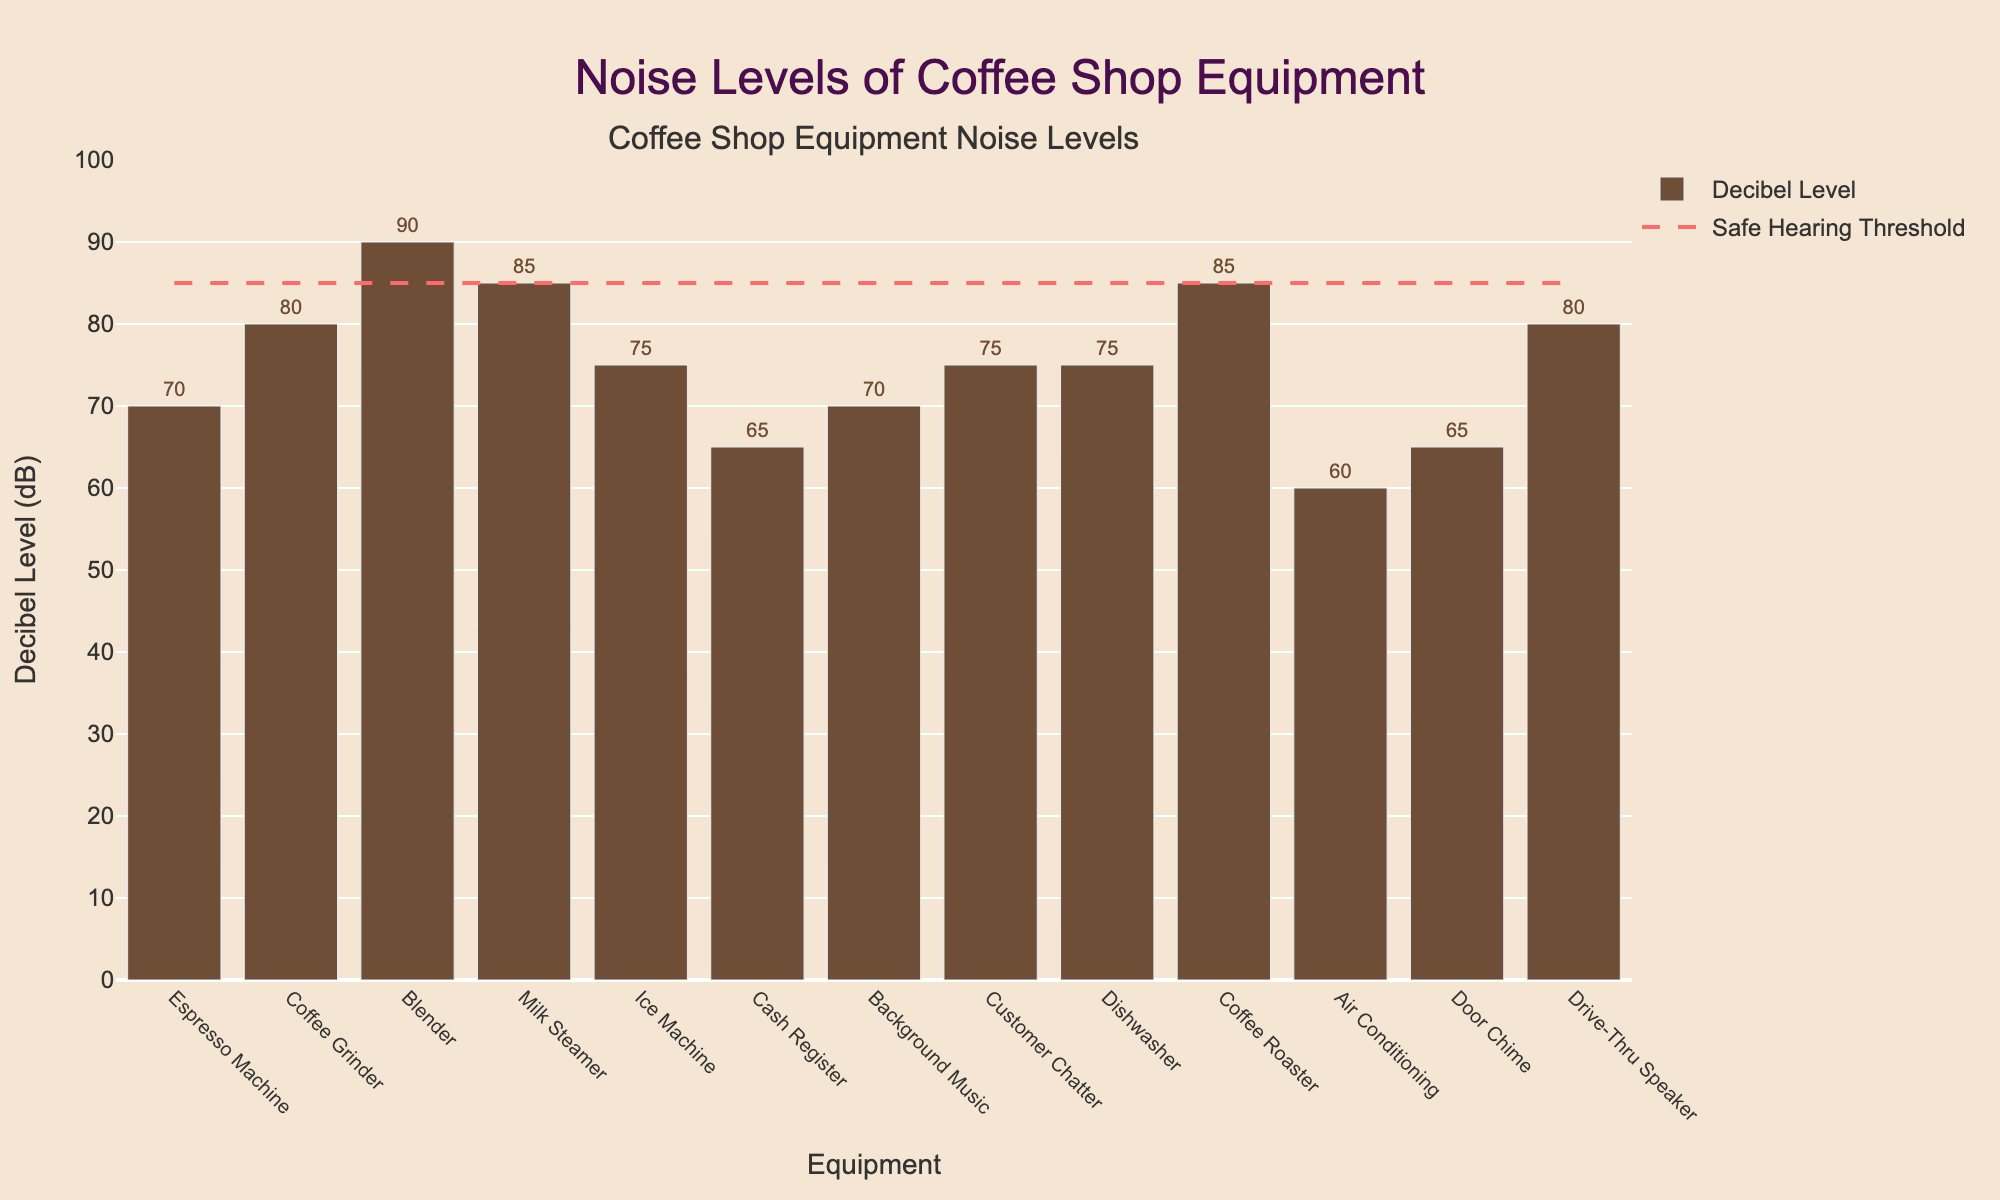Which equipment has the highest decibel level? By looking at the bar chart, the Blender has the highest bar, representing the highest decibel level among the equipment.
Answer: Blender Which equipment has decibel levels that exceed the safe hearing threshold? The bars that extend above the dashed line (safe hearing threshold at 85 dB) indicate equipment exceeding the threshold. These are Blender, Milk Steamer, Coffee Roaster, Coffee Grinder, and Drive-Thru Speaker.
Answer: Blender, Milk Steamer, Coffee Roaster, Coffee Grinder, Drive-Thru Speaker What is the difference in decibel levels between the loudest and quietest equipment? The loudest equipment is the Blender at 90 dB, and the quietest is the Air Conditioning at 60 dB. The difference is calculated as 90 dB - 60 dB.
Answer: 30 dB How many pieces of equipment have noise levels above 75 dB but below 85 dB? Based on the chart, the equipment within this range are the Milk Steamer, Drive-Thru Speaker, Coffee Grinder, Ice Machine, Customer Chatter, and Dishwasher.
Answer: 6 What average decibel level do Dishwasher, Ice Machine, and Coffee Roaster have? Add the decibel levels of Dishwasher (75 dB), Ice Machine (75 dB), and Coffee Roaster (85 dB), then divide by 3: (75 + 75 + 85) / 3.
Answer: 78.33 dB Does the Espresso Machine exceed the safe hearing threshold? The bar for the Espresso Machine reaches 70 dB, which is lower than the safe hearing threshold of 85 dB, as indicated by the dashed line.
Answer: No Which equipment has a decibel level equal to the safe hearing threshold? Bars reaching exactly the dashed line at 85 dB indicate equipment meeting the threshold. Based on the chart, these are the Milk Steamer and the Coffee Roaster.
Answer: Milk Steamer, Coffee Roaster Is the noise level of the Coffee Grinder greater than the Ice Machine? The bar for the Coffee Grinder reaches 80 dB, whereas the bar for the Ice Machine reaches 75 dB, so the Coffee Grinder has a higher decibel level.
Answer: Yes What is the sum of decibel levels for the Blender and the Cash Register? Add the decibel levels of Blender (90 dB) and Cash Register (65 dB): 90 + 65.
Answer: 155 dB Which has a higher noise level: the Background Music or the Customer Chatter? The bar for Customer Chatter reaches 75 dB, while the bar for Background Music reaches 70 dB, indicating that Customer Chatter is louder.
Answer: Customer Chatter 